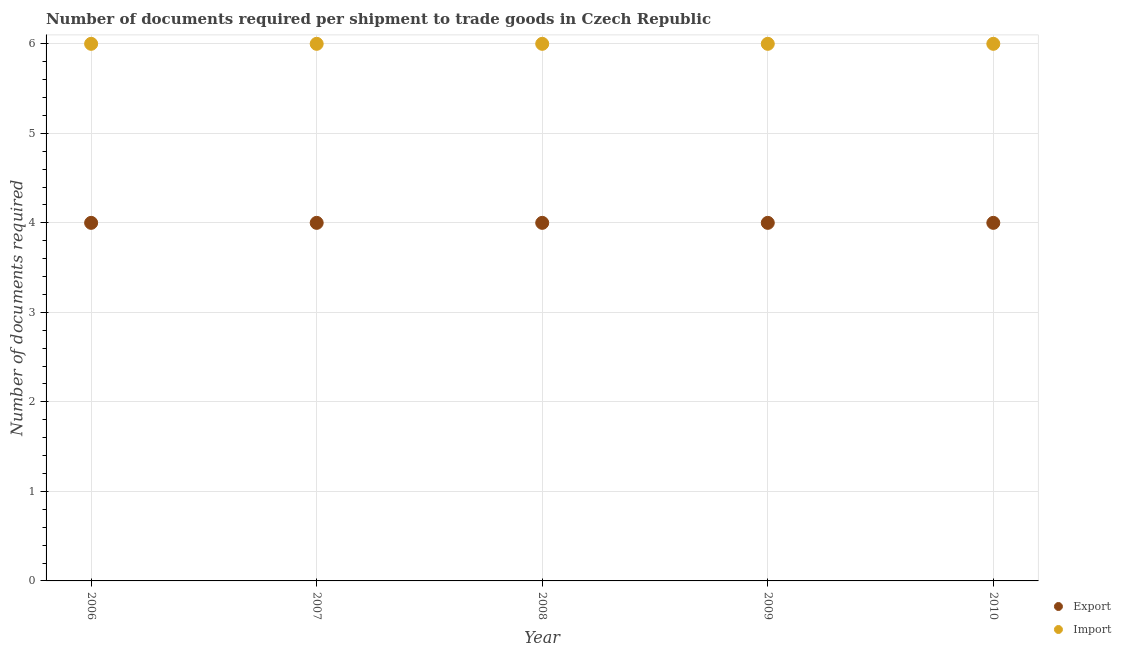How many different coloured dotlines are there?
Keep it short and to the point. 2. What is the number of documents required to import goods in 2008?
Give a very brief answer. 6. Across all years, what is the maximum number of documents required to export goods?
Offer a very short reply. 4. Across all years, what is the minimum number of documents required to export goods?
Give a very brief answer. 4. In which year was the number of documents required to export goods maximum?
Keep it short and to the point. 2006. In which year was the number of documents required to import goods minimum?
Your answer should be compact. 2006. What is the total number of documents required to import goods in the graph?
Your response must be concise. 30. What is the difference between the number of documents required to export goods in 2007 and the number of documents required to import goods in 2009?
Offer a very short reply. -2. What is the average number of documents required to import goods per year?
Provide a succinct answer. 6. In the year 2009, what is the difference between the number of documents required to export goods and number of documents required to import goods?
Your answer should be very brief. -2. Is the number of documents required to export goods in 2007 less than that in 2008?
Provide a short and direct response. No. Is the difference between the number of documents required to export goods in 2008 and 2010 greater than the difference between the number of documents required to import goods in 2008 and 2010?
Give a very brief answer. No. What is the difference between the highest and the lowest number of documents required to import goods?
Offer a very short reply. 0. In how many years, is the number of documents required to export goods greater than the average number of documents required to export goods taken over all years?
Provide a succinct answer. 0. Is the number of documents required to export goods strictly greater than the number of documents required to import goods over the years?
Your response must be concise. No. Is the number of documents required to export goods strictly less than the number of documents required to import goods over the years?
Give a very brief answer. Yes. How many years are there in the graph?
Provide a short and direct response. 5. Are the values on the major ticks of Y-axis written in scientific E-notation?
Give a very brief answer. No. Does the graph contain any zero values?
Your answer should be compact. No. Does the graph contain grids?
Offer a very short reply. Yes. How many legend labels are there?
Offer a very short reply. 2. What is the title of the graph?
Make the answer very short. Number of documents required per shipment to trade goods in Czech Republic. What is the label or title of the Y-axis?
Offer a very short reply. Number of documents required. What is the Number of documents required in Export in 2006?
Your answer should be very brief. 4. What is the Number of documents required in Import in 2006?
Give a very brief answer. 6. What is the Number of documents required of Export in 2007?
Offer a terse response. 4. What is the Number of documents required in Import in 2007?
Ensure brevity in your answer.  6. What is the Number of documents required in Export in 2010?
Give a very brief answer. 4. What is the Number of documents required of Import in 2010?
Your answer should be very brief. 6. Across all years, what is the maximum Number of documents required of Import?
Offer a terse response. 6. Across all years, what is the minimum Number of documents required in Import?
Offer a terse response. 6. What is the total Number of documents required of Export in the graph?
Offer a terse response. 20. What is the difference between the Number of documents required of Export in 2006 and that in 2008?
Your response must be concise. 0. What is the difference between the Number of documents required of Import in 2006 and that in 2008?
Give a very brief answer. 0. What is the difference between the Number of documents required of Export in 2006 and that in 2009?
Your response must be concise. 0. What is the difference between the Number of documents required of Import in 2007 and that in 2008?
Your response must be concise. 0. What is the difference between the Number of documents required in Export in 2007 and that in 2010?
Give a very brief answer. 0. What is the difference between the Number of documents required in Export in 2008 and that in 2009?
Ensure brevity in your answer.  0. What is the difference between the Number of documents required of Export in 2009 and that in 2010?
Your answer should be compact. 0. What is the difference between the Number of documents required of Import in 2009 and that in 2010?
Make the answer very short. 0. What is the difference between the Number of documents required of Export in 2006 and the Number of documents required of Import in 2008?
Your answer should be compact. -2. What is the difference between the Number of documents required in Export in 2006 and the Number of documents required in Import in 2009?
Offer a very short reply. -2. What is the difference between the Number of documents required of Export in 2006 and the Number of documents required of Import in 2010?
Ensure brevity in your answer.  -2. What is the difference between the Number of documents required of Export in 2007 and the Number of documents required of Import in 2010?
Make the answer very short. -2. What is the average Number of documents required of Export per year?
Your answer should be very brief. 4. In the year 2007, what is the difference between the Number of documents required of Export and Number of documents required of Import?
Your answer should be compact. -2. In the year 2009, what is the difference between the Number of documents required of Export and Number of documents required of Import?
Your answer should be very brief. -2. What is the ratio of the Number of documents required of Import in 2006 to that in 2007?
Your answer should be compact. 1. What is the ratio of the Number of documents required of Export in 2006 to that in 2009?
Provide a short and direct response. 1. What is the ratio of the Number of documents required in Import in 2006 to that in 2009?
Offer a very short reply. 1. What is the ratio of the Number of documents required in Export in 2006 to that in 2010?
Give a very brief answer. 1. What is the ratio of the Number of documents required in Import in 2007 to that in 2008?
Provide a short and direct response. 1. What is the ratio of the Number of documents required in Export in 2007 to that in 2009?
Offer a terse response. 1. What is the ratio of the Number of documents required of Import in 2007 to that in 2009?
Provide a short and direct response. 1. What is the ratio of the Number of documents required of Export in 2008 to that in 2009?
Offer a terse response. 1. What is the ratio of the Number of documents required in Import in 2008 to that in 2009?
Offer a terse response. 1. What is the ratio of the Number of documents required in Export in 2008 to that in 2010?
Provide a short and direct response. 1. What is the ratio of the Number of documents required in Import in 2008 to that in 2010?
Give a very brief answer. 1. What is the ratio of the Number of documents required in Import in 2009 to that in 2010?
Provide a succinct answer. 1. What is the difference between the highest and the second highest Number of documents required of Import?
Ensure brevity in your answer.  0. What is the difference between the highest and the lowest Number of documents required in Export?
Provide a short and direct response. 0. What is the difference between the highest and the lowest Number of documents required in Import?
Your answer should be compact. 0. 